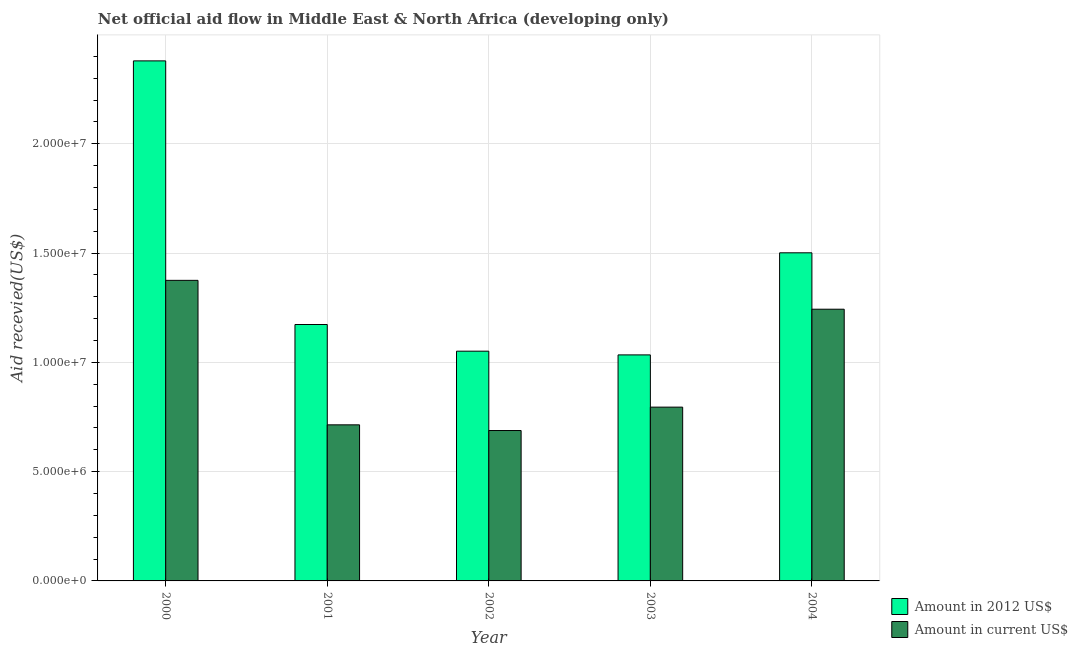How many groups of bars are there?
Keep it short and to the point. 5. Are the number of bars per tick equal to the number of legend labels?
Provide a short and direct response. Yes. What is the label of the 3rd group of bars from the left?
Give a very brief answer. 2002. In how many cases, is the number of bars for a given year not equal to the number of legend labels?
Ensure brevity in your answer.  0. What is the amount of aid received(expressed in 2012 us$) in 2000?
Your answer should be very brief. 2.38e+07. Across all years, what is the maximum amount of aid received(expressed in 2012 us$)?
Your answer should be very brief. 2.38e+07. Across all years, what is the minimum amount of aid received(expressed in 2012 us$)?
Your answer should be compact. 1.03e+07. In which year was the amount of aid received(expressed in 2012 us$) minimum?
Ensure brevity in your answer.  2003. What is the total amount of aid received(expressed in 2012 us$) in the graph?
Keep it short and to the point. 7.14e+07. What is the difference between the amount of aid received(expressed in 2012 us$) in 2002 and that in 2003?
Offer a very short reply. 1.70e+05. What is the difference between the amount of aid received(expressed in us$) in 2003 and the amount of aid received(expressed in 2012 us$) in 2004?
Ensure brevity in your answer.  -4.48e+06. What is the average amount of aid received(expressed in us$) per year?
Keep it short and to the point. 9.63e+06. In how many years, is the amount of aid received(expressed in 2012 us$) greater than 19000000 US$?
Your response must be concise. 1. What is the ratio of the amount of aid received(expressed in us$) in 2000 to that in 2001?
Offer a very short reply. 1.93. Is the amount of aid received(expressed in us$) in 2001 less than that in 2004?
Your answer should be compact. Yes. Is the difference between the amount of aid received(expressed in us$) in 2000 and 2004 greater than the difference between the amount of aid received(expressed in 2012 us$) in 2000 and 2004?
Provide a short and direct response. No. What is the difference between the highest and the second highest amount of aid received(expressed in us$)?
Offer a very short reply. 1.32e+06. What is the difference between the highest and the lowest amount of aid received(expressed in 2012 us$)?
Offer a very short reply. 1.34e+07. In how many years, is the amount of aid received(expressed in us$) greater than the average amount of aid received(expressed in us$) taken over all years?
Make the answer very short. 2. Is the sum of the amount of aid received(expressed in us$) in 2000 and 2002 greater than the maximum amount of aid received(expressed in 2012 us$) across all years?
Your answer should be compact. Yes. What does the 1st bar from the left in 2000 represents?
Keep it short and to the point. Amount in 2012 US$. What does the 2nd bar from the right in 2004 represents?
Offer a very short reply. Amount in 2012 US$. Are all the bars in the graph horizontal?
Give a very brief answer. No. Does the graph contain grids?
Provide a succinct answer. Yes. How many legend labels are there?
Make the answer very short. 2. How are the legend labels stacked?
Give a very brief answer. Vertical. What is the title of the graph?
Offer a terse response. Net official aid flow in Middle East & North Africa (developing only). Does "Taxes on profits and capital gains" appear as one of the legend labels in the graph?
Ensure brevity in your answer.  No. What is the label or title of the X-axis?
Your answer should be compact. Year. What is the label or title of the Y-axis?
Offer a terse response. Aid recevied(US$). What is the Aid recevied(US$) in Amount in 2012 US$ in 2000?
Provide a short and direct response. 2.38e+07. What is the Aid recevied(US$) of Amount in current US$ in 2000?
Provide a succinct answer. 1.38e+07. What is the Aid recevied(US$) of Amount in 2012 US$ in 2001?
Your response must be concise. 1.17e+07. What is the Aid recevied(US$) in Amount in current US$ in 2001?
Provide a short and direct response. 7.14e+06. What is the Aid recevied(US$) of Amount in 2012 US$ in 2002?
Ensure brevity in your answer.  1.05e+07. What is the Aid recevied(US$) in Amount in current US$ in 2002?
Your response must be concise. 6.88e+06. What is the Aid recevied(US$) in Amount in 2012 US$ in 2003?
Ensure brevity in your answer.  1.03e+07. What is the Aid recevied(US$) in Amount in current US$ in 2003?
Provide a succinct answer. 7.95e+06. What is the Aid recevied(US$) of Amount in 2012 US$ in 2004?
Provide a short and direct response. 1.50e+07. What is the Aid recevied(US$) of Amount in current US$ in 2004?
Your answer should be compact. 1.24e+07. Across all years, what is the maximum Aid recevied(US$) of Amount in 2012 US$?
Ensure brevity in your answer.  2.38e+07. Across all years, what is the maximum Aid recevied(US$) of Amount in current US$?
Your answer should be compact. 1.38e+07. Across all years, what is the minimum Aid recevied(US$) in Amount in 2012 US$?
Offer a terse response. 1.03e+07. Across all years, what is the minimum Aid recevied(US$) in Amount in current US$?
Provide a short and direct response. 6.88e+06. What is the total Aid recevied(US$) of Amount in 2012 US$ in the graph?
Keep it short and to the point. 7.14e+07. What is the total Aid recevied(US$) of Amount in current US$ in the graph?
Keep it short and to the point. 4.82e+07. What is the difference between the Aid recevied(US$) of Amount in 2012 US$ in 2000 and that in 2001?
Give a very brief answer. 1.21e+07. What is the difference between the Aid recevied(US$) of Amount in current US$ in 2000 and that in 2001?
Give a very brief answer. 6.61e+06. What is the difference between the Aid recevied(US$) of Amount in 2012 US$ in 2000 and that in 2002?
Your answer should be compact. 1.33e+07. What is the difference between the Aid recevied(US$) in Amount in current US$ in 2000 and that in 2002?
Provide a succinct answer. 6.87e+06. What is the difference between the Aid recevied(US$) in Amount in 2012 US$ in 2000 and that in 2003?
Your answer should be very brief. 1.34e+07. What is the difference between the Aid recevied(US$) in Amount in current US$ in 2000 and that in 2003?
Provide a short and direct response. 5.80e+06. What is the difference between the Aid recevied(US$) of Amount in 2012 US$ in 2000 and that in 2004?
Ensure brevity in your answer.  8.78e+06. What is the difference between the Aid recevied(US$) in Amount in current US$ in 2000 and that in 2004?
Offer a very short reply. 1.32e+06. What is the difference between the Aid recevied(US$) in Amount in 2012 US$ in 2001 and that in 2002?
Offer a terse response. 1.22e+06. What is the difference between the Aid recevied(US$) of Amount in 2012 US$ in 2001 and that in 2003?
Make the answer very short. 1.39e+06. What is the difference between the Aid recevied(US$) in Amount in current US$ in 2001 and that in 2003?
Offer a very short reply. -8.10e+05. What is the difference between the Aid recevied(US$) in Amount in 2012 US$ in 2001 and that in 2004?
Offer a terse response. -3.28e+06. What is the difference between the Aid recevied(US$) of Amount in current US$ in 2001 and that in 2004?
Your answer should be compact. -5.29e+06. What is the difference between the Aid recevied(US$) in Amount in 2012 US$ in 2002 and that in 2003?
Ensure brevity in your answer.  1.70e+05. What is the difference between the Aid recevied(US$) of Amount in current US$ in 2002 and that in 2003?
Your response must be concise. -1.07e+06. What is the difference between the Aid recevied(US$) of Amount in 2012 US$ in 2002 and that in 2004?
Your response must be concise. -4.50e+06. What is the difference between the Aid recevied(US$) in Amount in current US$ in 2002 and that in 2004?
Your response must be concise. -5.55e+06. What is the difference between the Aid recevied(US$) of Amount in 2012 US$ in 2003 and that in 2004?
Offer a terse response. -4.67e+06. What is the difference between the Aid recevied(US$) in Amount in current US$ in 2003 and that in 2004?
Offer a terse response. -4.48e+06. What is the difference between the Aid recevied(US$) of Amount in 2012 US$ in 2000 and the Aid recevied(US$) of Amount in current US$ in 2001?
Make the answer very short. 1.66e+07. What is the difference between the Aid recevied(US$) of Amount in 2012 US$ in 2000 and the Aid recevied(US$) of Amount in current US$ in 2002?
Your answer should be very brief. 1.69e+07. What is the difference between the Aid recevied(US$) in Amount in 2012 US$ in 2000 and the Aid recevied(US$) in Amount in current US$ in 2003?
Your answer should be very brief. 1.58e+07. What is the difference between the Aid recevied(US$) of Amount in 2012 US$ in 2000 and the Aid recevied(US$) of Amount in current US$ in 2004?
Offer a terse response. 1.14e+07. What is the difference between the Aid recevied(US$) of Amount in 2012 US$ in 2001 and the Aid recevied(US$) of Amount in current US$ in 2002?
Provide a short and direct response. 4.85e+06. What is the difference between the Aid recevied(US$) of Amount in 2012 US$ in 2001 and the Aid recevied(US$) of Amount in current US$ in 2003?
Your answer should be compact. 3.78e+06. What is the difference between the Aid recevied(US$) of Amount in 2012 US$ in 2001 and the Aid recevied(US$) of Amount in current US$ in 2004?
Offer a terse response. -7.00e+05. What is the difference between the Aid recevied(US$) of Amount in 2012 US$ in 2002 and the Aid recevied(US$) of Amount in current US$ in 2003?
Make the answer very short. 2.56e+06. What is the difference between the Aid recevied(US$) in Amount in 2012 US$ in 2002 and the Aid recevied(US$) in Amount in current US$ in 2004?
Your response must be concise. -1.92e+06. What is the difference between the Aid recevied(US$) of Amount in 2012 US$ in 2003 and the Aid recevied(US$) of Amount in current US$ in 2004?
Make the answer very short. -2.09e+06. What is the average Aid recevied(US$) in Amount in 2012 US$ per year?
Ensure brevity in your answer.  1.43e+07. What is the average Aid recevied(US$) of Amount in current US$ per year?
Keep it short and to the point. 9.63e+06. In the year 2000, what is the difference between the Aid recevied(US$) of Amount in 2012 US$ and Aid recevied(US$) of Amount in current US$?
Keep it short and to the point. 1.00e+07. In the year 2001, what is the difference between the Aid recevied(US$) in Amount in 2012 US$ and Aid recevied(US$) in Amount in current US$?
Offer a very short reply. 4.59e+06. In the year 2002, what is the difference between the Aid recevied(US$) in Amount in 2012 US$ and Aid recevied(US$) in Amount in current US$?
Keep it short and to the point. 3.63e+06. In the year 2003, what is the difference between the Aid recevied(US$) of Amount in 2012 US$ and Aid recevied(US$) of Amount in current US$?
Provide a short and direct response. 2.39e+06. In the year 2004, what is the difference between the Aid recevied(US$) in Amount in 2012 US$ and Aid recevied(US$) in Amount in current US$?
Ensure brevity in your answer.  2.58e+06. What is the ratio of the Aid recevied(US$) of Amount in 2012 US$ in 2000 to that in 2001?
Keep it short and to the point. 2.03. What is the ratio of the Aid recevied(US$) in Amount in current US$ in 2000 to that in 2001?
Your answer should be compact. 1.93. What is the ratio of the Aid recevied(US$) of Amount in 2012 US$ in 2000 to that in 2002?
Give a very brief answer. 2.26. What is the ratio of the Aid recevied(US$) of Amount in current US$ in 2000 to that in 2002?
Your response must be concise. 2. What is the ratio of the Aid recevied(US$) of Amount in 2012 US$ in 2000 to that in 2003?
Offer a terse response. 2.3. What is the ratio of the Aid recevied(US$) in Amount in current US$ in 2000 to that in 2003?
Offer a very short reply. 1.73. What is the ratio of the Aid recevied(US$) in Amount in 2012 US$ in 2000 to that in 2004?
Offer a very short reply. 1.58. What is the ratio of the Aid recevied(US$) in Amount in current US$ in 2000 to that in 2004?
Offer a very short reply. 1.11. What is the ratio of the Aid recevied(US$) of Amount in 2012 US$ in 2001 to that in 2002?
Your answer should be compact. 1.12. What is the ratio of the Aid recevied(US$) of Amount in current US$ in 2001 to that in 2002?
Your answer should be very brief. 1.04. What is the ratio of the Aid recevied(US$) of Amount in 2012 US$ in 2001 to that in 2003?
Offer a terse response. 1.13. What is the ratio of the Aid recevied(US$) in Amount in current US$ in 2001 to that in 2003?
Your answer should be compact. 0.9. What is the ratio of the Aid recevied(US$) of Amount in 2012 US$ in 2001 to that in 2004?
Provide a succinct answer. 0.78. What is the ratio of the Aid recevied(US$) of Amount in current US$ in 2001 to that in 2004?
Your answer should be compact. 0.57. What is the ratio of the Aid recevied(US$) of Amount in 2012 US$ in 2002 to that in 2003?
Ensure brevity in your answer.  1.02. What is the ratio of the Aid recevied(US$) in Amount in current US$ in 2002 to that in 2003?
Offer a very short reply. 0.87. What is the ratio of the Aid recevied(US$) of Amount in 2012 US$ in 2002 to that in 2004?
Offer a very short reply. 0.7. What is the ratio of the Aid recevied(US$) in Amount in current US$ in 2002 to that in 2004?
Provide a succinct answer. 0.55. What is the ratio of the Aid recevied(US$) in Amount in 2012 US$ in 2003 to that in 2004?
Your response must be concise. 0.69. What is the ratio of the Aid recevied(US$) in Amount in current US$ in 2003 to that in 2004?
Offer a very short reply. 0.64. What is the difference between the highest and the second highest Aid recevied(US$) in Amount in 2012 US$?
Offer a terse response. 8.78e+06. What is the difference between the highest and the second highest Aid recevied(US$) in Amount in current US$?
Keep it short and to the point. 1.32e+06. What is the difference between the highest and the lowest Aid recevied(US$) in Amount in 2012 US$?
Give a very brief answer. 1.34e+07. What is the difference between the highest and the lowest Aid recevied(US$) in Amount in current US$?
Your response must be concise. 6.87e+06. 